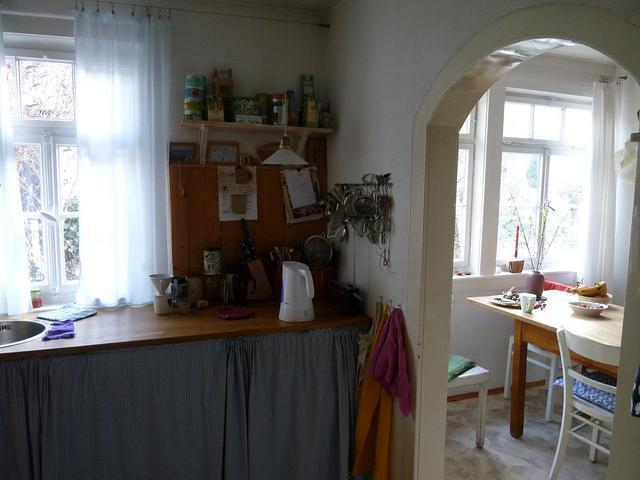How many dining tables are there?
Give a very brief answer. 2. How many people on the vase are holding a vase?
Give a very brief answer. 0. 